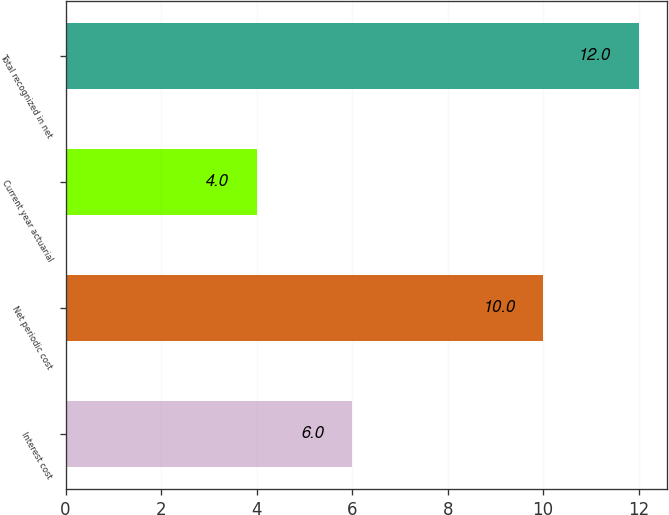Convert chart to OTSL. <chart><loc_0><loc_0><loc_500><loc_500><bar_chart><fcel>Interest cost<fcel>Net periodic cost<fcel>Current year actuarial<fcel>Total recognized in net<nl><fcel>6<fcel>10<fcel>4<fcel>12<nl></chart> 